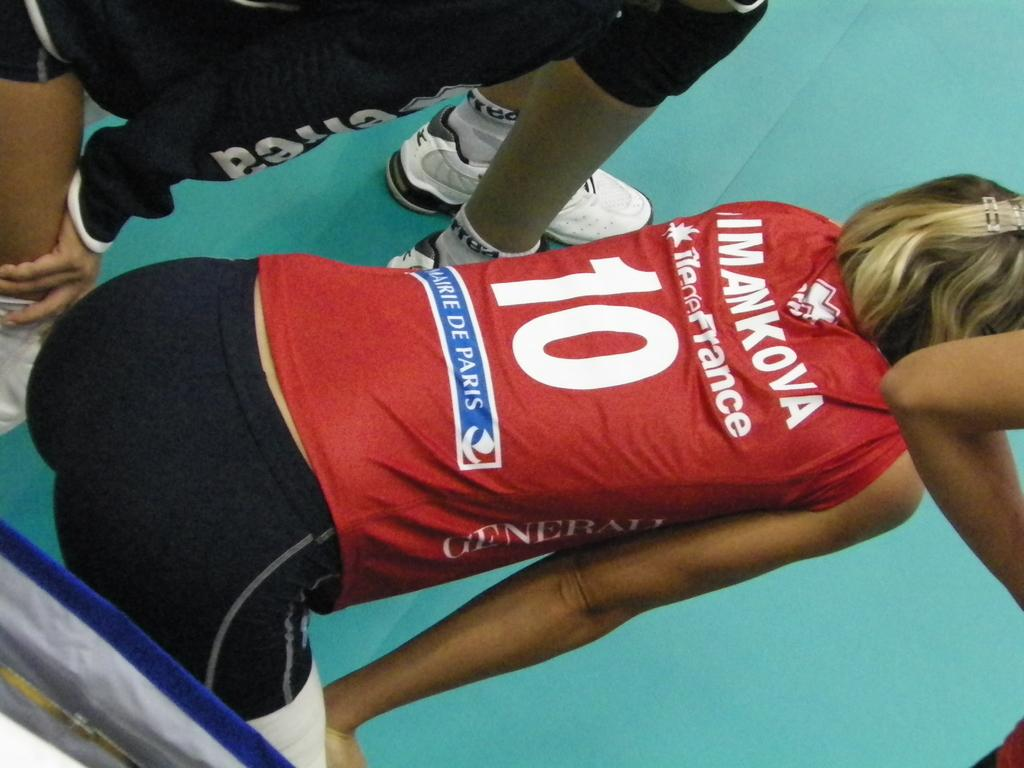<image>
Provide a brief description of the given image. Women athlete is bent over and she is wearing a shirt that says Imankova 10. 